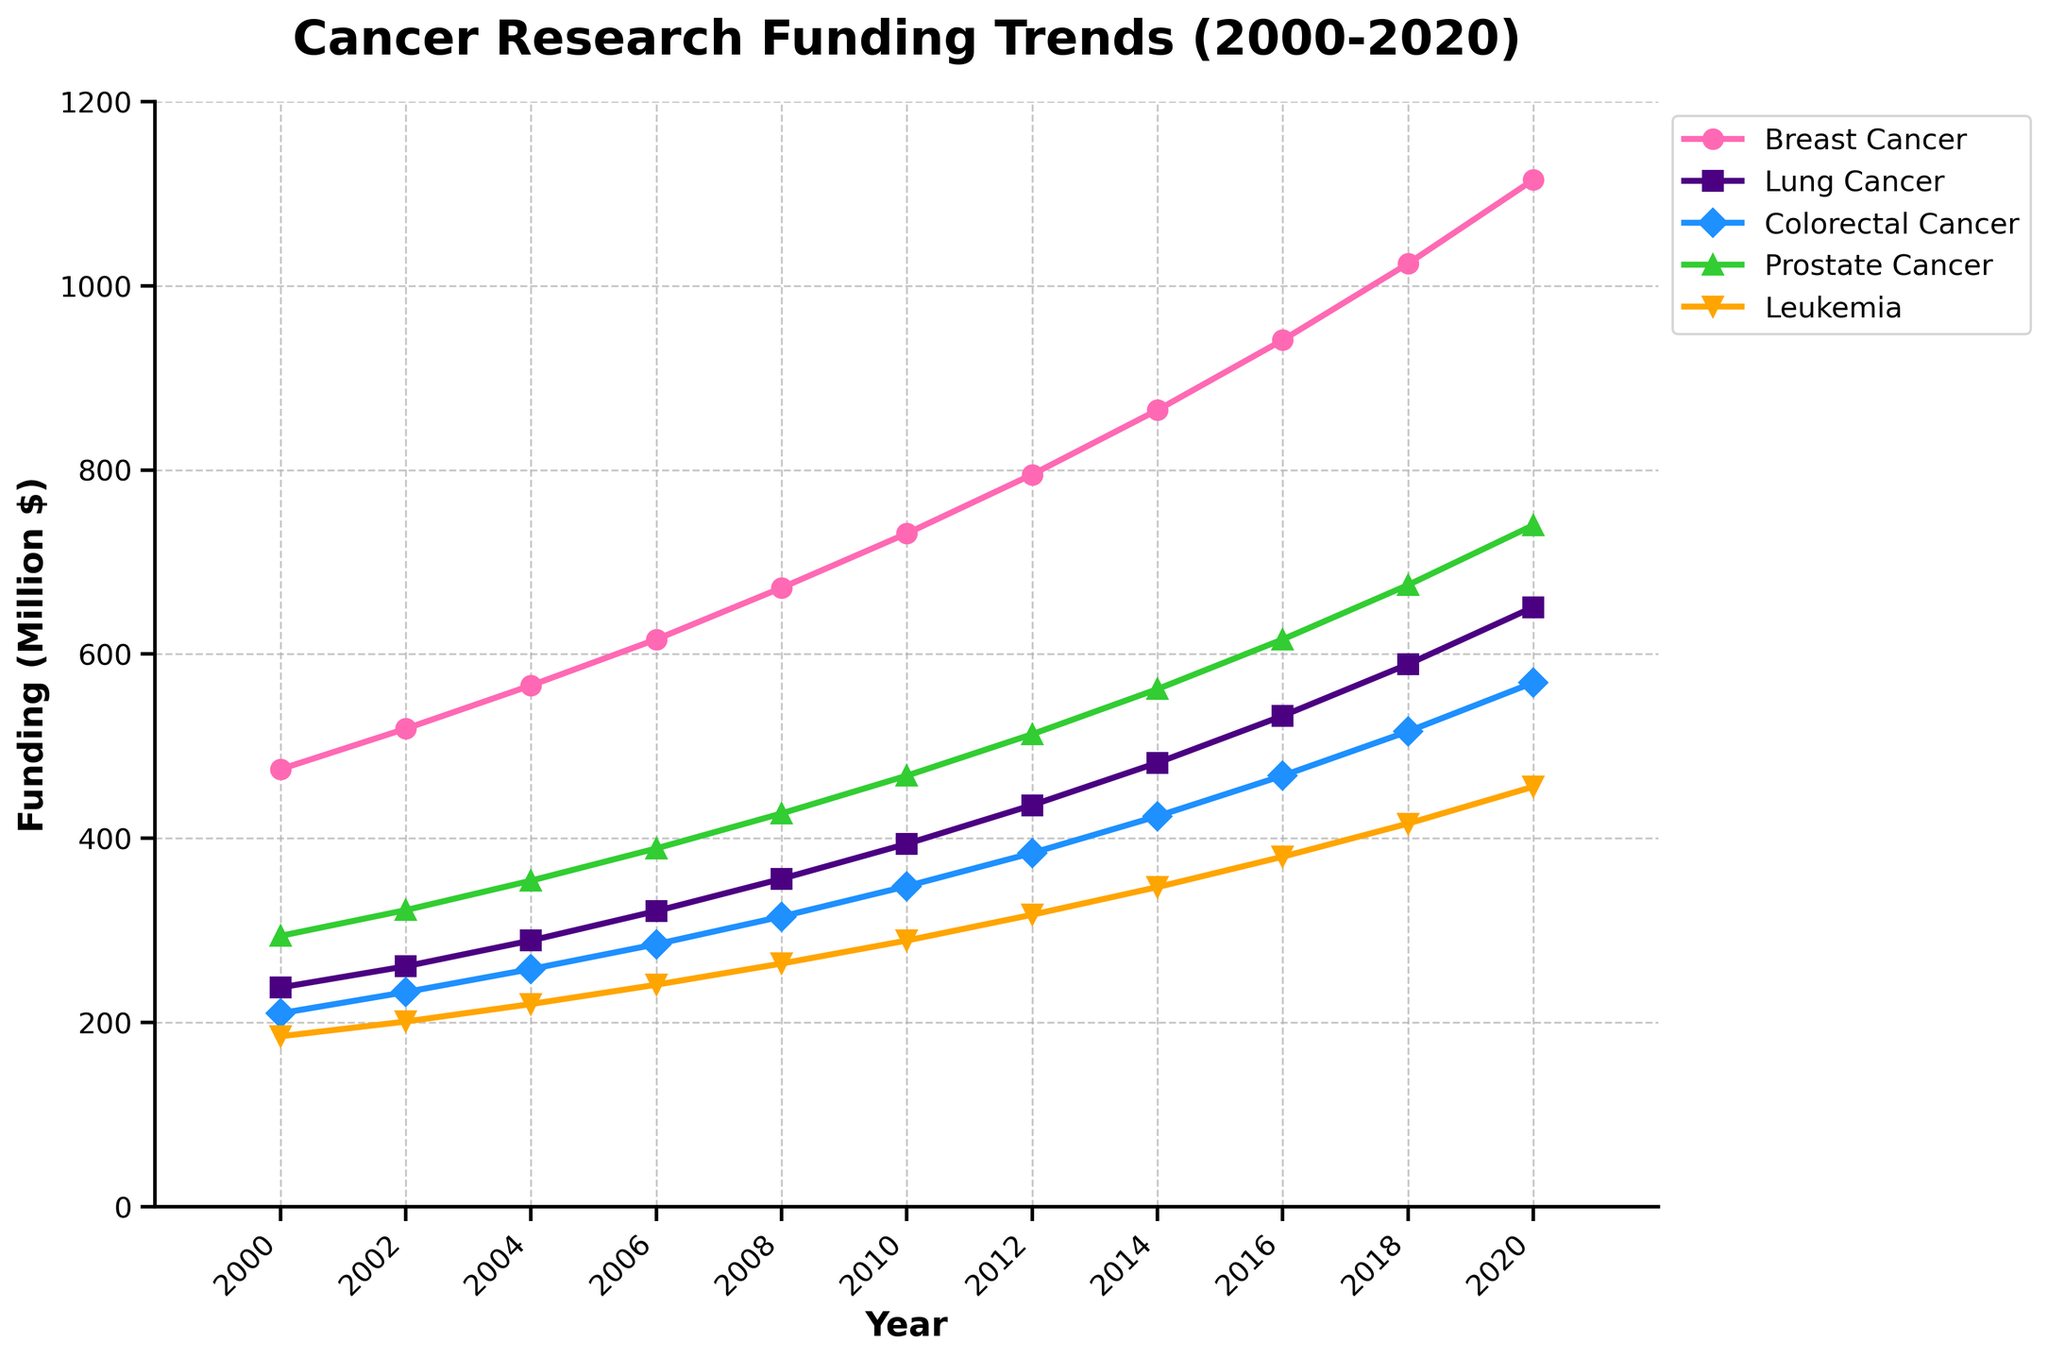What is the trend for Breast Cancer funding from 2000 to 2020? From the figure, observe the Breast Cancer curve which starts at $475 million in 2000 and increases steadily over the years reaching $1115 million in 2020. The clear upward trajectory indicates a consistent increase in funding.
Answer: Consistent increase Which cancer type received the highest funding in 2020? In the year 2020, compare the endpoints of all lines representing different cancer types. The Breast Cancer line has the highest value at $1115 million.
Answer: Breast Cancer By how much did funding for Leukemia increase from 2000 to 2020? Subtract the funding value in 2000 ($185 million) from the funding value in 2020 ($456 million). The difference is $456 million - $185 million = $271 million.
Answer: $271 million What was the trend in funding for Lung Cancer between 2010 and 2020? Observe the Lung Cancer trendline between the years 2010 and 2020. It starts at $394 million in 2010 and ends at $651 million in 2020, showing a steady increase.
Answer: Steady increase How did funding for Colorectal Cancer in 2004 compare to funding for Prostate Cancer in the same year? Look at the values for Colorectal Cancer and Prostate Cancer in 2004 on the figure. Colorectal Cancer has $258 million while Prostate Cancer has $354 million. Hence, Prostate Cancer funding was higher.
Answer: Prostate Cancer funding was higher What is the difference in funding between Breast Cancer and Lung Cancer in 2020? Subtract the Lung Cancer funding value ($651 million) from the Breast Cancer funding value ($1115 million) for the year 2020. The difference is $1115 million - $651 million = $464 million.
Answer: $464 million Which cancer type showed the most significant increase in funding from 2000 to 2020? Compare the difference between the 2020 and 2000 values for each cancer type. Breast Cancer had the biggest change increasing from $475 million in 2000 to $1115 million in 2020, a $640 million rise.
Answer: Breast Cancer Estimate the average yearly funding for Prostate Cancer from 2000 to 2020. Sum all the funding values for Prostate Cancer from 2000 to 2020: 294 + 322 + 354 + 389 + 427 + 468 + 513 + 562 + 616 + 675 + 740 = 5360. Then, divide by the number of years (11). 5360 / 11 ≈ 487.27 million dollars.
Answer: ≈ 487.27 million dollars What visual indicators help distinguish between different types of cancer funding trends on the figure? The figure uses different colors and markers for each cancer type: pink circles for Breast Cancer, purple squares for Lung Cancer, blue diamonds for Colorectal Cancer, green triangles for Prostate Cancer, and orange upside-down triangles for Leukemia.
Answer: Different colors and markers 